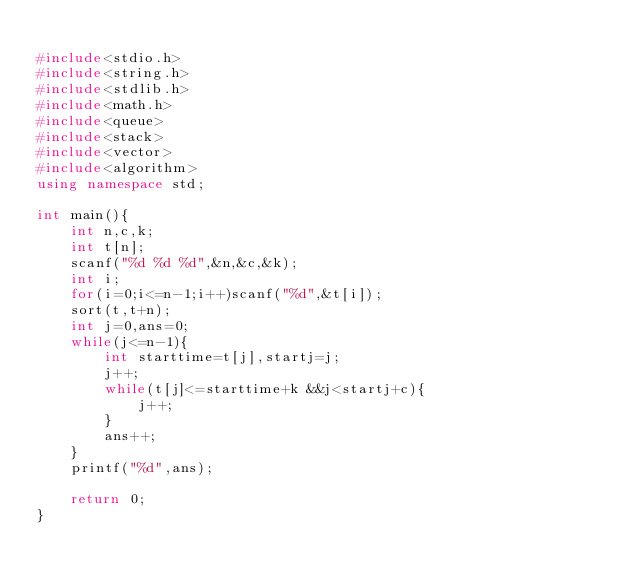Convert code to text. <code><loc_0><loc_0><loc_500><loc_500><_C++_>
#include<stdio.h>
#include<string.h>
#include<stdlib.h>
#include<math.h>
#include<queue>
#include<stack>
#include<vector>
#include<algorithm>
using namespace std;

int main(){
    int n,c,k;
    int t[n];
    scanf("%d %d %d",&n,&c,&k);
    int i;
    for(i=0;i<=n-1;i++)scanf("%d",&t[i]);
    sort(t,t+n);
    int j=0,ans=0;
    while(j<=n-1){
        int starttime=t[j],startj=j;
        j++;
        while(t[j]<=starttime+k &&j<startj+c){
            j++;
        }
        ans++;
    }
    printf("%d",ans);
    
    return 0;
}
</code> 